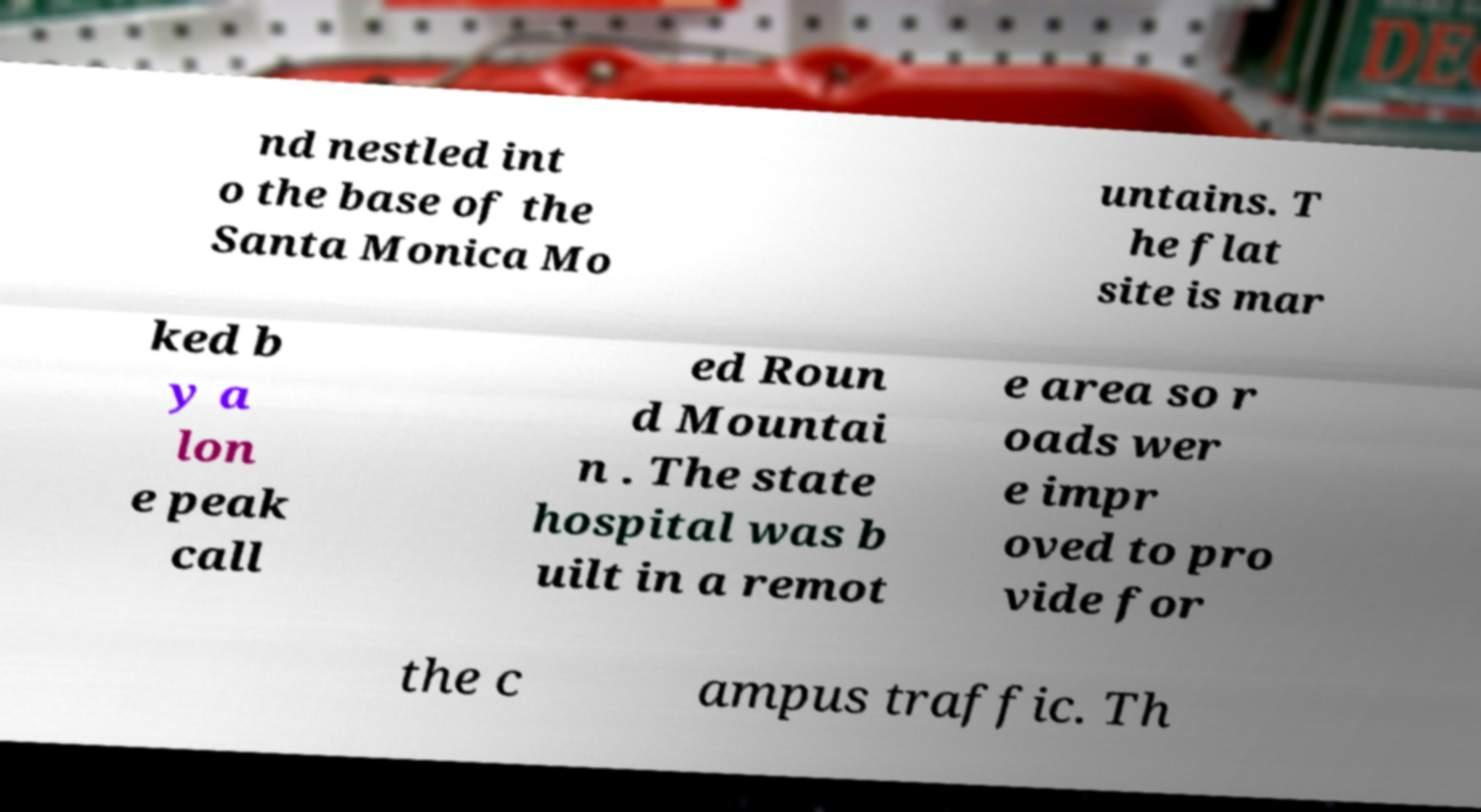There's text embedded in this image that I need extracted. Can you transcribe it verbatim? nd nestled int o the base of the Santa Monica Mo untains. T he flat site is mar ked b y a lon e peak call ed Roun d Mountai n . The state hospital was b uilt in a remot e area so r oads wer e impr oved to pro vide for the c ampus traffic. Th 